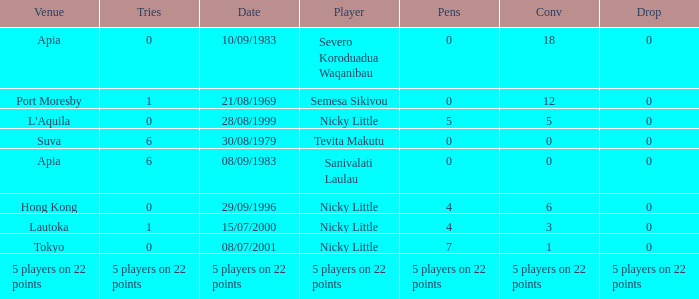How many conversions did Severo Koroduadua Waqanibau have when he has 0 pens? 18.0. 